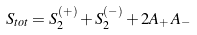Convert formula to latex. <formula><loc_0><loc_0><loc_500><loc_500>S _ { t o t } = S _ { 2 } ^ { ( + ) } + S _ { 2 } ^ { ( - ) } + 2 A _ { + } \, A _ { - }</formula> 